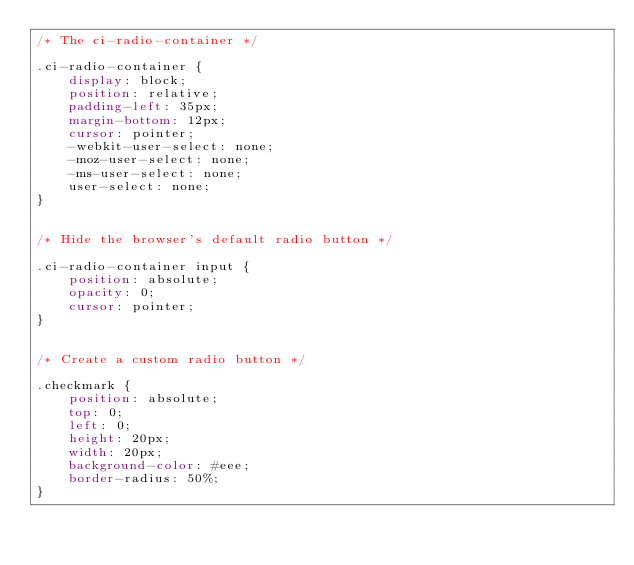Convert code to text. <code><loc_0><loc_0><loc_500><loc_500><_CSS_>/* The ci-radio-container */

.ci-radio-container {
    display: block;
    position: relative;
    padding-left: 35px;
    margin-bottom: 12px;
    cursor: pointer;
    -webkit-user-select: none;
    -moz-user-select: none;
    -ms-user-select: none;
    user-select: none;
}


/* Hide the browser's default radio button */

.ci-radio-container input {
    position: absolute;
    opacity: 0;
    cursor: pointer;
}


/* Create a custom radio button */

.checkmark {
    position: absolute;
    top: 0;
    left: 0;
    height: 20px;
    width: 20px;
    background-color: #eee;
    border-radius: 50%;
}

</code> 